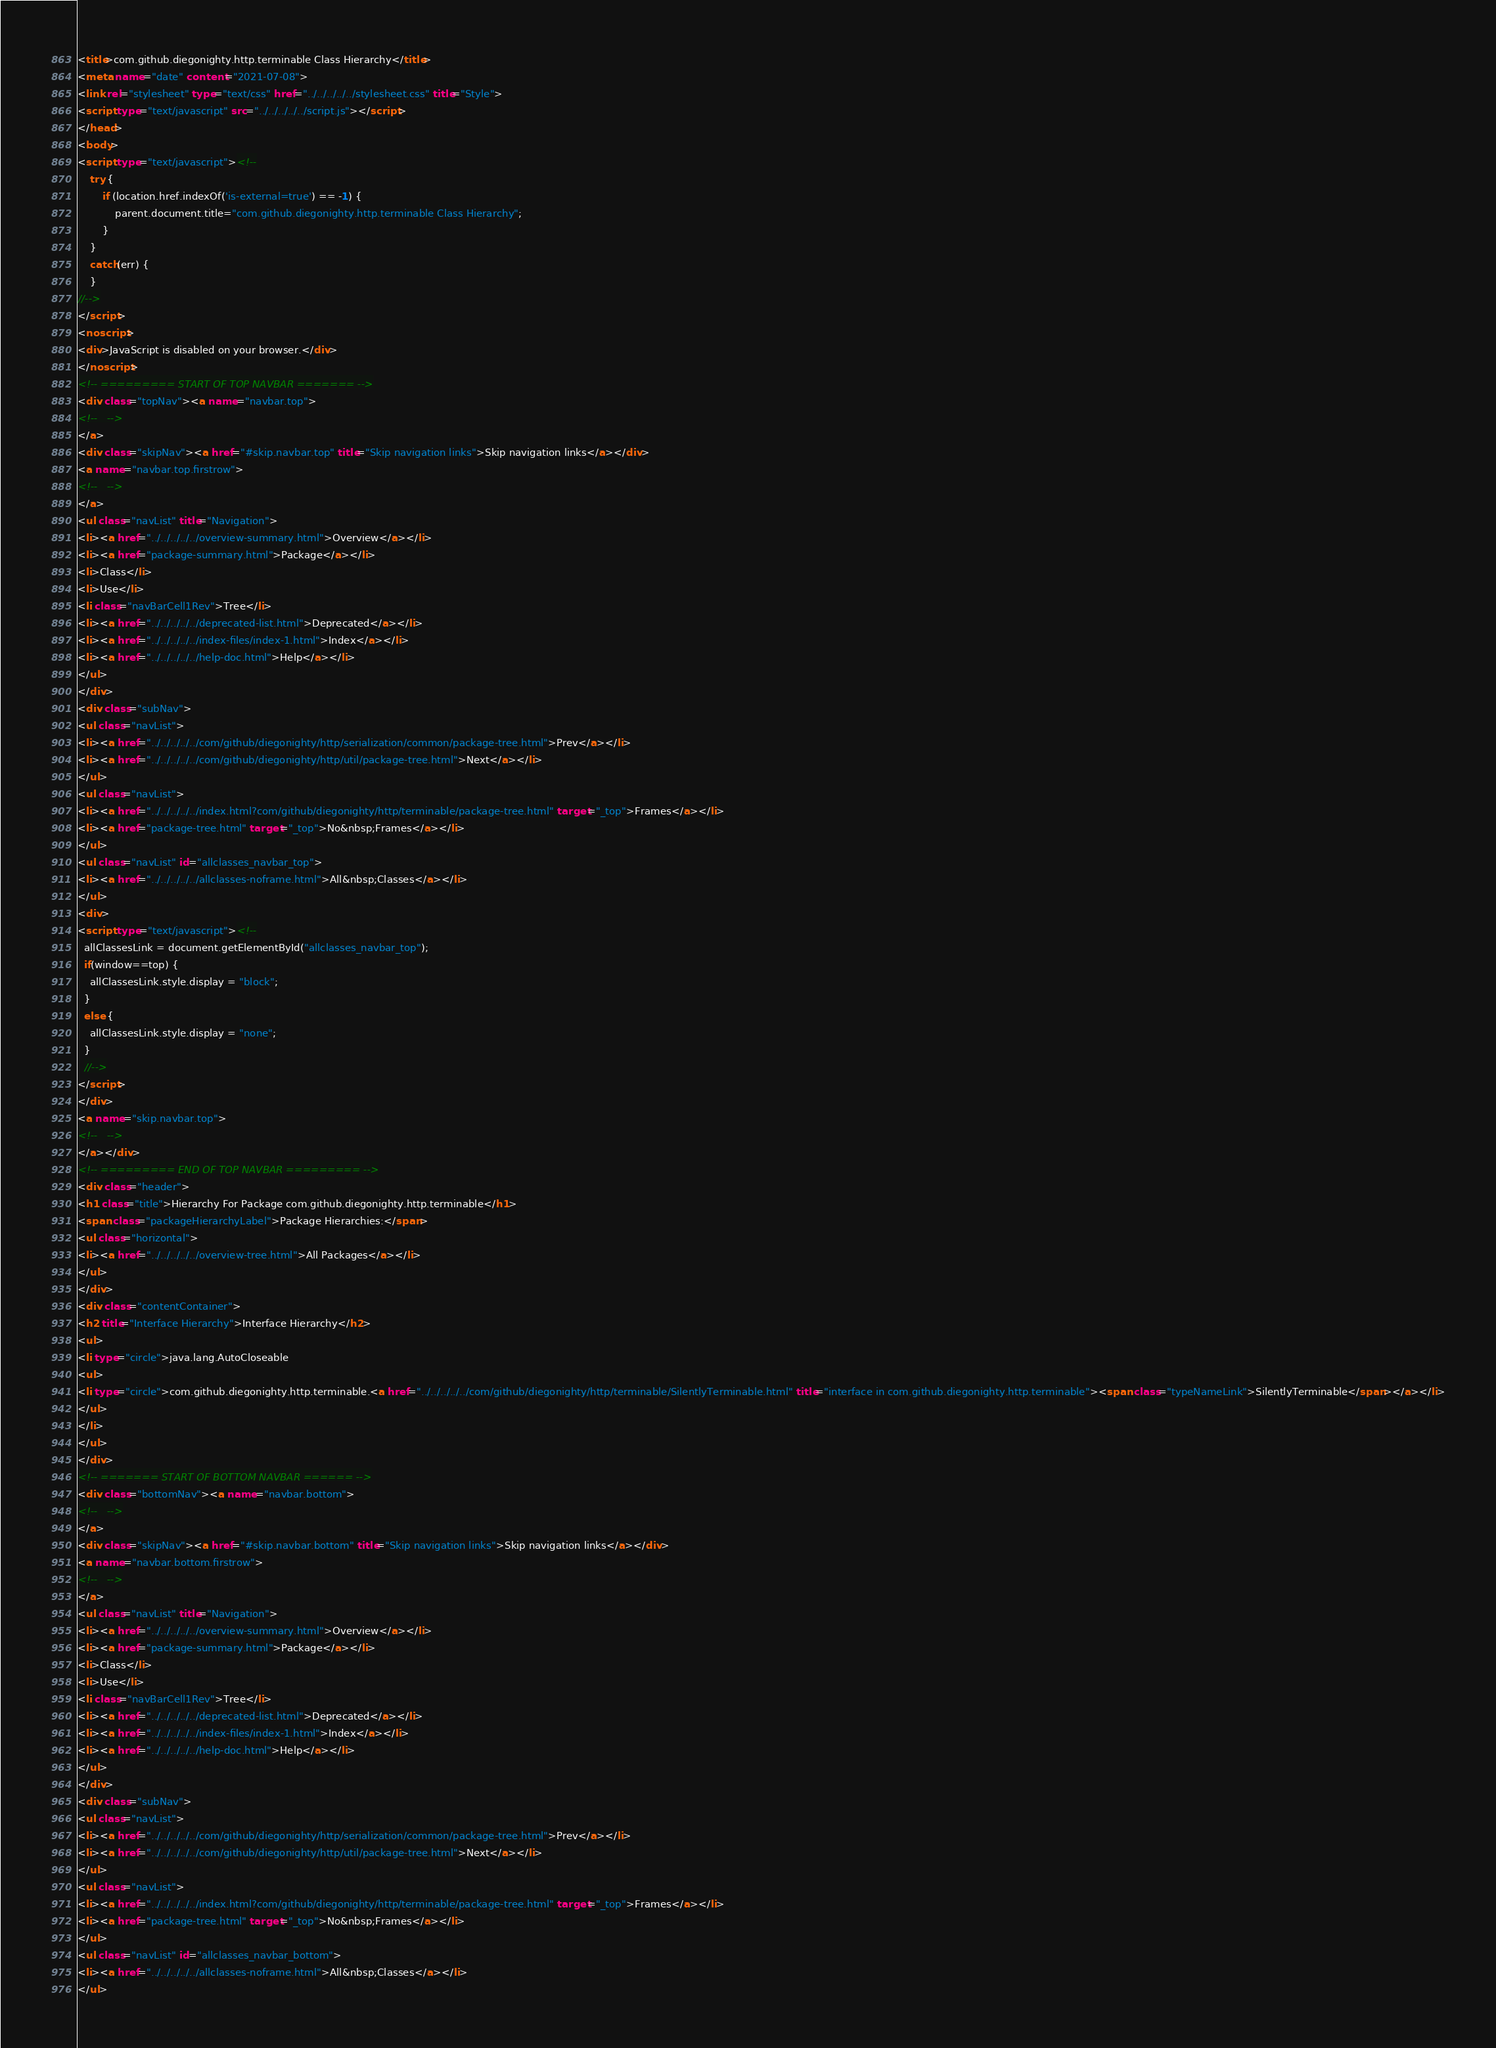Convert code to text. <code><loc_0><loc_0><loc_500><loc_500><_HTML_><title>com.github.diegonighty.http.terminable Class Hierarchy</title>
<meta name="date" content="2021-07-08">
<link rel="stylesheet" type="text/css" href="../../../../../stylesheet.css" title="Style">
<script type="text/javascript" src="../../../../../script.js"></script>
</head>
<body>
<script type="text/javascript"><!--
    try {
        if (location.href.indexOf('is-external=true') == -1) {
            parent.document.title="com.github.diegonighty.http.terminable Class Hierarchy";
        }
    }
    catch(err) {
    }
//-->
</script>
<noscript>
<div>JavaScript is disabled on your browser.</div>
</noscript>
<!-- ========= START OF TOP NAVBAR ======= -->
<div class="topNav"><a name="navbar.top">
<!--   -->
</a>
<div class="skipNav"><a href="#skip.navbar.top" title="Skip navigation links">Skip navigation links</a></div>
<a name="navbar.top.firstrow">
<!--   -->
</a>
<ul class="navList" title="Navigation">
<li><a href="../../../../../overview-summary.html">Overview</a></li>
<li><a href="package-summary.html">Package</a></li>
<li>Class</li>
<li>Use</li>
<li class="navBarCell1Rev">Tree</li>
<li><a href="../../../../../deprecated-list.html">Deprecated</a></li>
<li><a href="../../../../../index-files/index-1.html">Index</a></li>
<li><a href="../../../../../help-doc.html">Help</a></li>
</ul>
</div>
<div class="subNav">
<ul class="navList">
<li><a href="../../../../../com/github/diegonighty/http/serialization/common/package-tree.html">Prev</a></li>
<li><a href="../../../../../com/github/diegonighty/http/util/package-tree.html">Next</a></li>
</ul>
<ul class="navList">
<li><a href="../../../../../index.html?com/github/diegonighty/http/terminable/package-tree.html" target="_top">Frames</a></li>
<li><a href="package-tree.html" target="_top">No&nbsp;Frames</a></li>
</ul>
<ul class="navList" id="allclasses_navbar_top">
<li><a href="../../../../../allclasses-noframe.html">All&nbsp;Classes</a></li>
</ul>
<div>
<script type="text/javascript"><!--
  allClassesLink = document.getElementById("allclasses_navbar_top");
  if(window==top) {
    allClassesLink.style.display = "block";
  }
  else {
    allClassesLink.style.display = "none";
  }
  //-->
</script>
</div>
<a name="skip.navbar.top">
<!--   -->
</a></div>
<!-- ========= END OF TOP NAVBAR ========= -->
<div class="header">
<h1 class="title">Hierarchy For Package com.github.diegonighty.http.terminable</h1>
<span class="packageHierarchyLabel">Package Hierarchies:</span>
<ul class="horizontal">
<li><a href="../../../../../overview-tree.html">All Packages</a></li>
</ul>
</div>
<div class="contentContainer">
<h2 title="Interface Hierarchy">Interface Hierarchy</h2>
<ul>
<li type="circle">java.lang.AutoCloseable
<ul>
<li type="circle">com.github.diegonighty.http.terminable.<a href="../../../../../com/github/diegonighty/http/terminable/SilentlyTerminable.html" title="interface in com.github.diegonighty.http.terminable"><span class="typeNameLink">SilentlyTerminable</span></a></li>
</ul>
</li>
</ul>
</div>
<!-- ======= START OF BOTTOM NAVBAR ====== -->
<div class="bottomNav"><a name="navbar.bottom">
<!--   -->
</a>
<div class="skipNav"><a href="#skip.navbar.bottom" title="Skip navigation links">Skip navigation links</a></div>
<a name="navbar.bottom.firstrow">
<!--   -->
</a>
<ul class="navList" title="Navigation">
<li><a href="../../../../../overview-summary.html">Overview</a></li>
<li><a href="package-summary.html">Package</a></li>
<li>Class</li>
<li>Use</li>
<li class="navBarCell1Rev">Tree</li>
<li><a href="../../../../../deprecated-list.html">Deprecated</a></li>
<li><a href="../../../../../index-files/index-1.html">Index</a></li>
<li><a href="../../../../../help-doc.html">Help</a></li>
</ul>
</div>
<div class="subNav">
<ul class="navList">
<li><a href="../../../../../com/github/diegonighty/http/serialization/common/package-tree.html">Prev</a></li>
<li><a href="../../../../../com/github/diegonighty/http/util/package-tree.html">Next</a></li>
</ul>
<ul class="navList">
<li><a href="../../../../../index.html?com/github/diegonighty/http/terminable/package-tree.html" target="_top">Frames</a></li>
<li><a href="package-tree.html" target="_top">No&nbsp;Frames</a></li>
</ul>
<ul class="navList" id="allclasses_navbar_bottom">
<li><a href="../../../../../allclasses-noframe.html">All&nbsp;Classes</a></li>
</ul></code> 